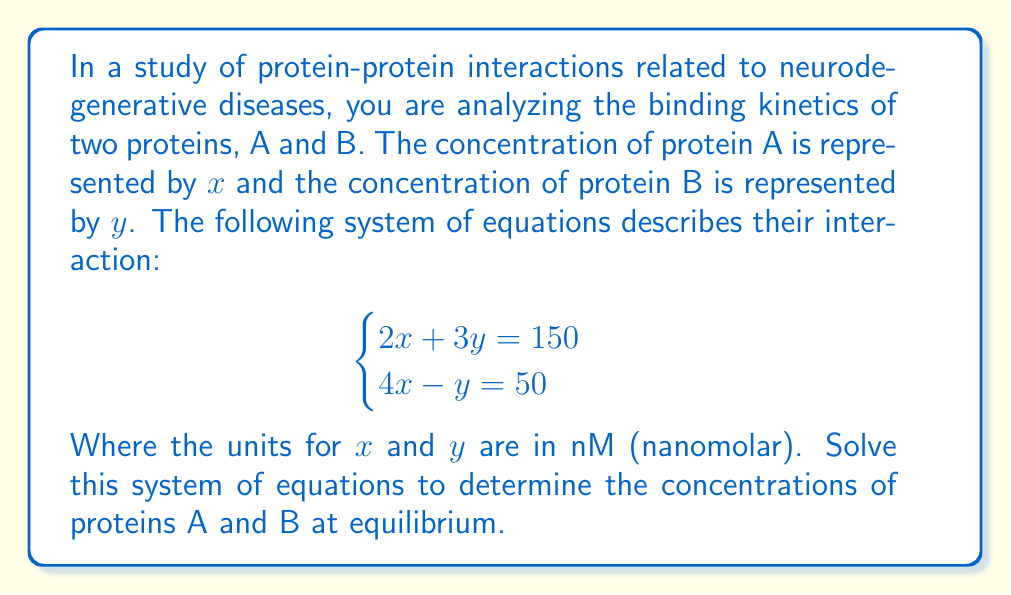Help me with this question. To solve this system of equations, we'll use the substitution method:

1) From the second equation, isolate y:
   $4x - y = 50$
   $-y = 50 - 4x$
   $y = 4x - 50$

2) Substitute this expression for y into the first equation:
   $2x + 3(4x - 50) = 150$

3) Simplify:
   $2x + 12x - 150 = 150$
   $14x - 150 = 150$

4) Solve for x:
   $14x = 300$
   $x = \frac{300}{14} = 21.43$ nM

5) Now that we know x, substitute back into the equation from step 1 to find y:
   $y = 4(21.43) - 50$
   $y = 85.72 - 50 = 35.72$ nM

6) Round to two decimal places for the final answer:
   $x = 21.43$ nM
   $y = 35.72$ nM

These values represent the equilibrium concentrations of proteins A and B, respectively.
Answer: $x = 21.43$ nM, $y = 35.72$ nM 